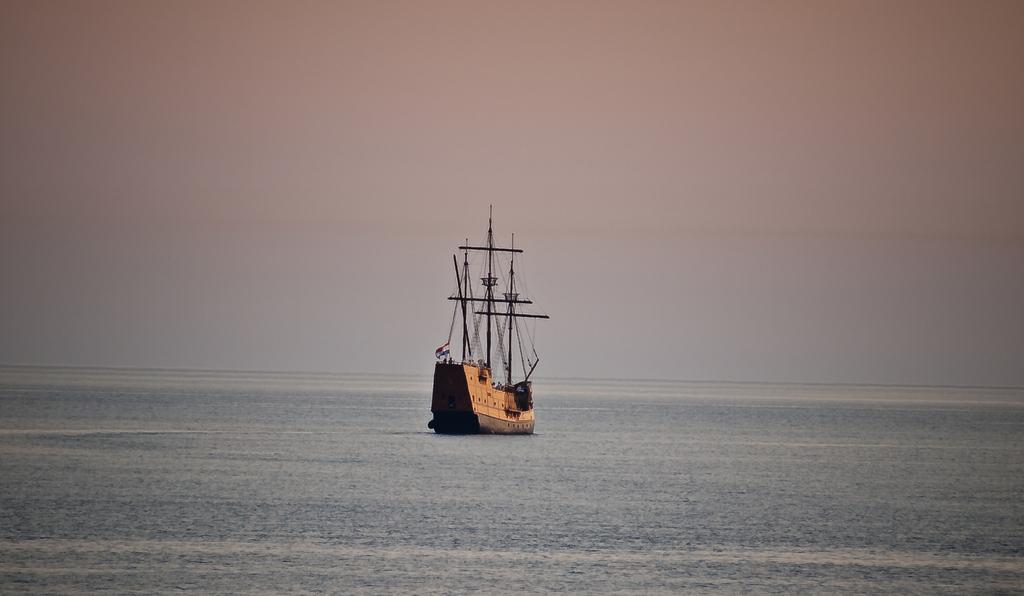What is the main subject of the image? There is a ship in the image. Where is the ship located? The ship is on the sea. How would you describe the sky in the image? The sky appears gloomy in the image. What type of government is depicted on the ship in the image? There is no depiction of a government on the ship in the image. How does the ship make the passengers feel in the image? The image does not convey the feelings of the passengers; it only shows the ship on the sea with a gloomy sky. 